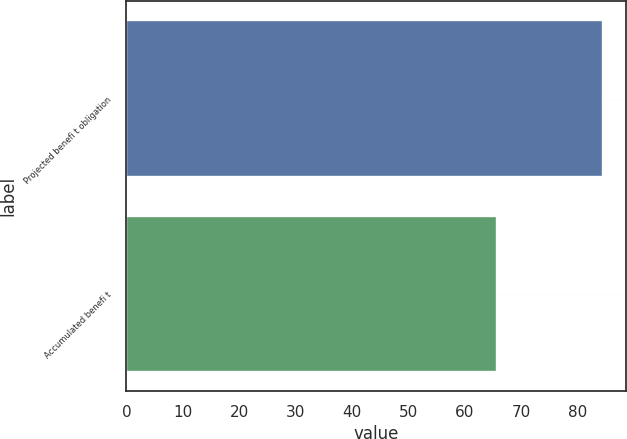<chart> <loc_0><loc_0><loc_500><loc_500><bar_chart><fcel>Projected benefi t obligation<fcel>Accumulated benefi t<nl><fcel>84.5<fcel>65.7<nl></chart> 